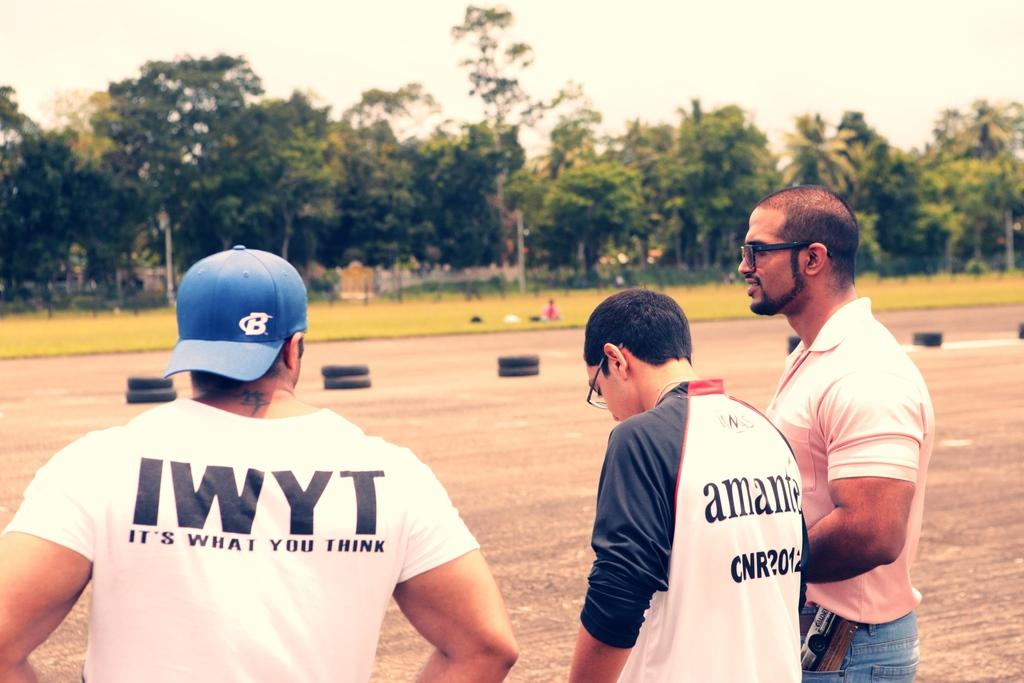<image>
Describe the image concisely. IWYT is short for It's What You Think! 